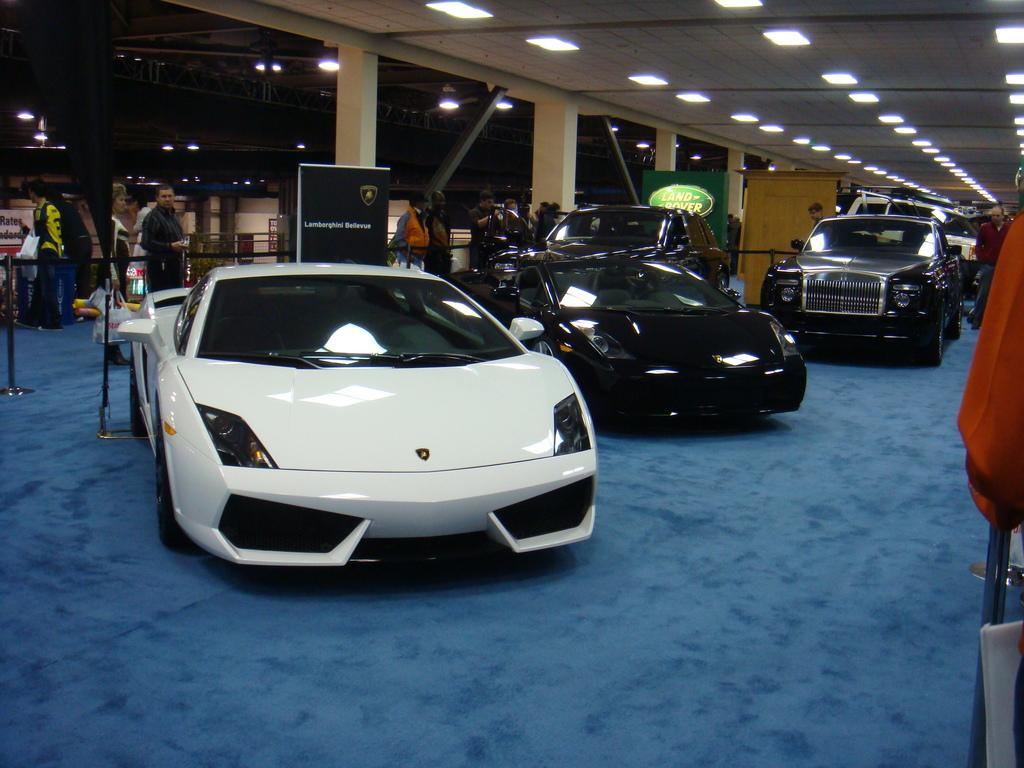What can be seen in the image? There are vehicles in the image. Can you describe the vehicles? The vehicles are in different colors. What is the floor like in the image? The vehicles are on a blue color floor. What can be seen in the background of the image? There are boards, poles, lights, and people visible in the background. How would you describe the lighting in the background? The background is dark. What type of tent can be seen in the image? There is no tent present in the image. Can you hear any sounds coming from the vehicles in the image? The image is a still picture, so it does not include any sounds. What time of day is it in the image? The image does not provide any information about the time of day, but the dark background suggests it might be nighttime or in a dimly lit area. 